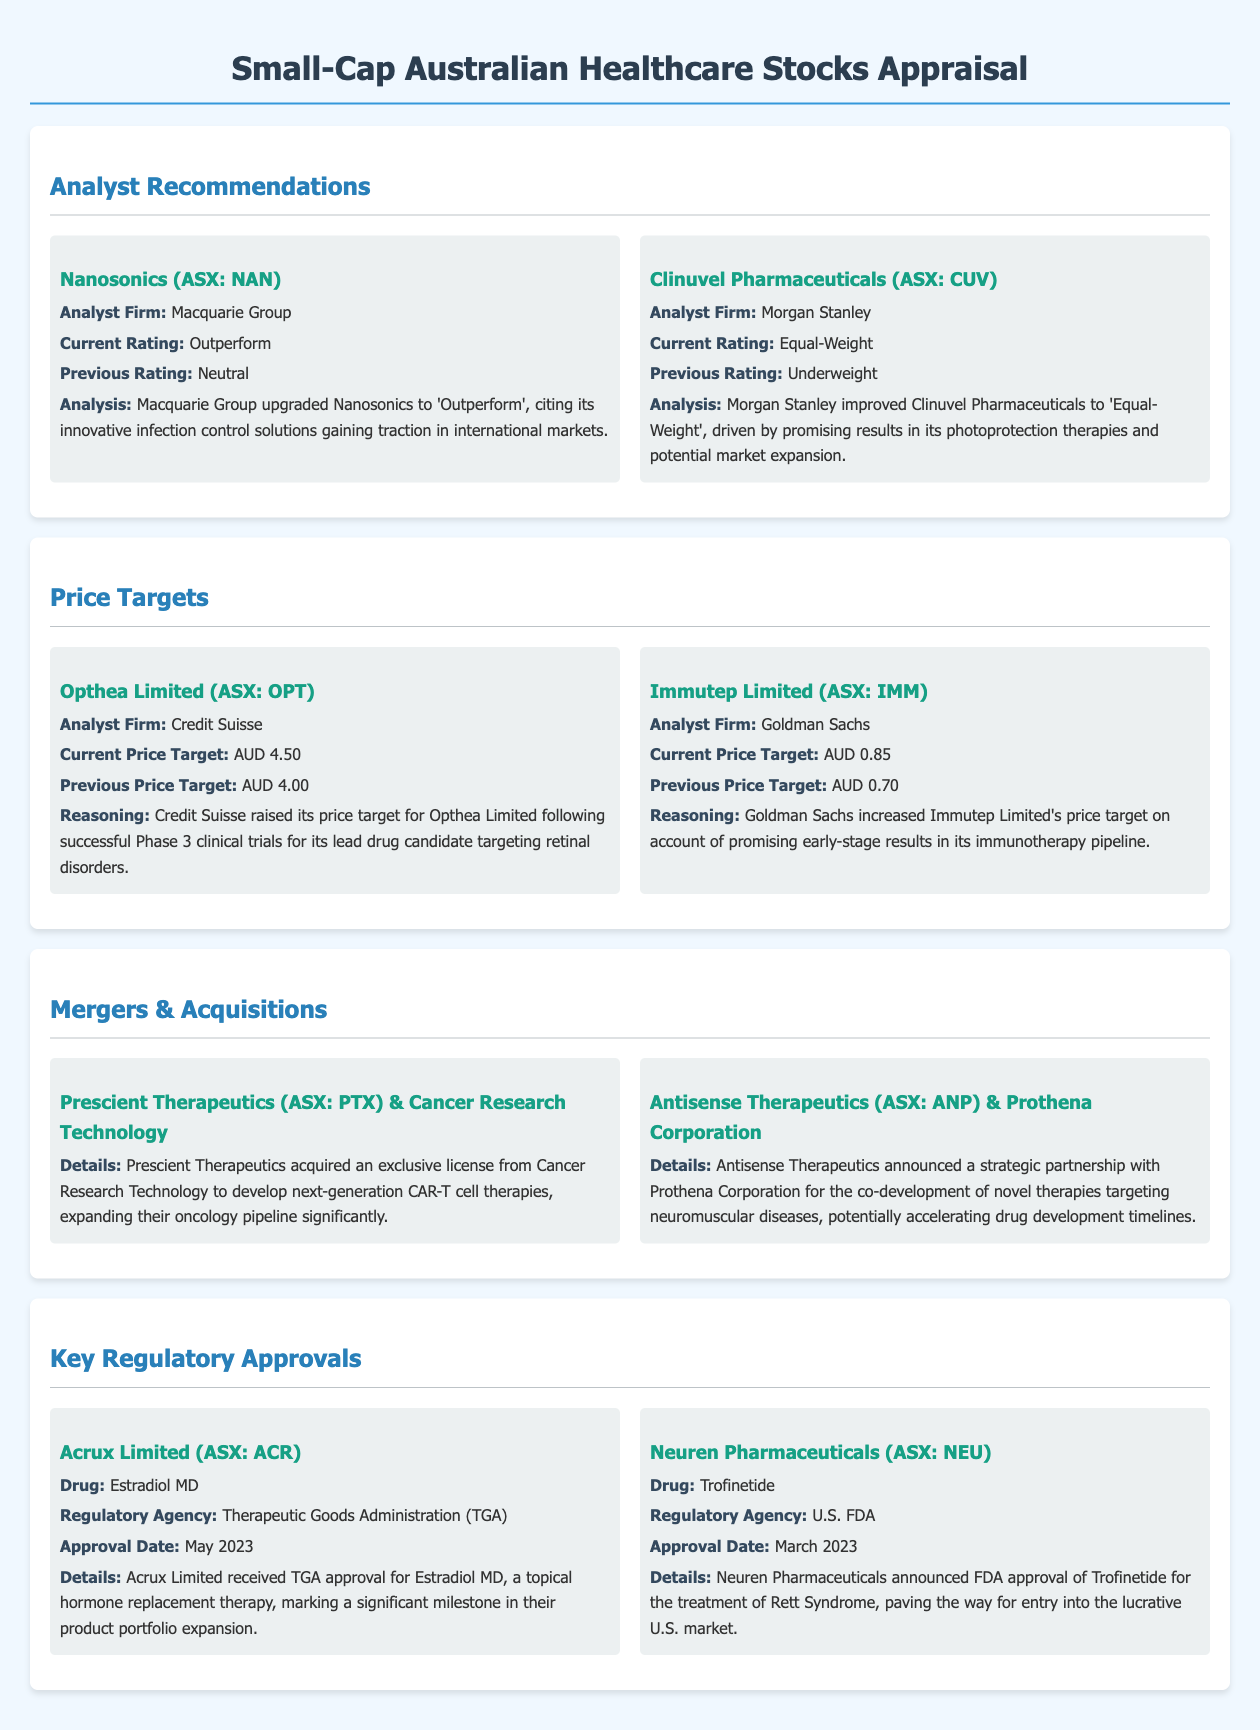What is the current rating for Nanosonics? Nanosonics has been upgraded to 'Outperform', which is the current rating provided by Macquarie Group.
Answer: Outperform What is the new price target for Opthea Limited? Credit Suisse raised the price target for Opthea Limited to AUD 4.50.
Answer: AUD 4.50 Who acquired the license from Cancer Research Technology? Prescient Therapeutics is the company that acquired an exclusive license from Cancer Research Technology.
Answer: Prescient Therapeutics When did Acrux Limited receive TGA approval for Estradiol MD? Acrux Limited received TGA approval for Estradiol MD in May 2023.
Answer: May 2023 What was the previous price target for Immutep Limited? The previous price target for Immutep Limited was AUD 0.70, as stated by Goldman Sachs.
Answer: AUD 0.70 Which analyst firm rated Clinuvel Pharmaceuticals as Equal-Weight? Morgan Stanley is the analyst firm that rated Clinuvel Pharmaceuticals as Equal-Weight.
Answer: Morgan Stanley What is the drug approved by Neuren Pharmaceuticals for Rett Syndrome? The drug approved by Neuren Pharmaceuticals for Rett Syndrome is Trofinetide.
Answer: Trofinetide What type of therapies is Antisense Therapeutics co-developing with Prothena Corporation? Antisense Therapeutics is co-developing novel therapies targeting neuromuscular diseases.
Answer: novel therapies targeting neuromuscular diseases What was the previous rating for Nanosonics before it was upgraded? The previous rating for Nanosonics was Neutral, which is noted in the analyst's analysis.
Answer: Neutral 